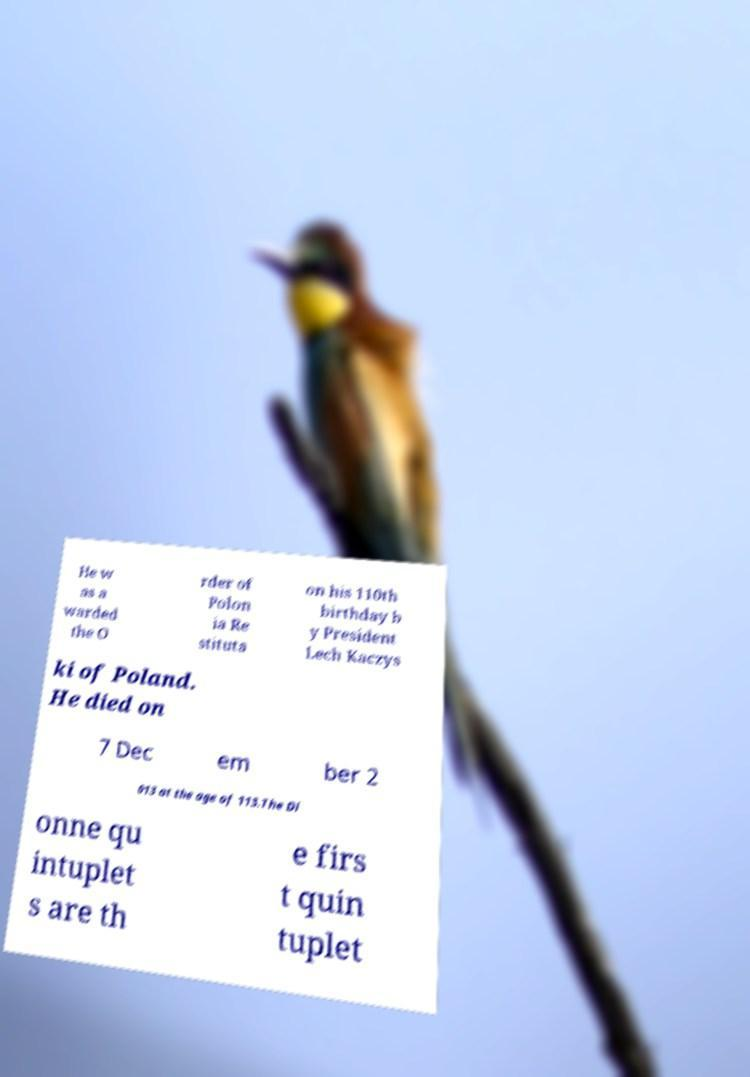Please identify and transcribe the text found in this image. He w as a warded the O rder of Polon ia Re stituta on his 110th birthday b y President Lech Kaczys ki of Poland. He died on 7 Dec em ber 2 013 at the age of 113.The Di onne qu intuplet s are th e firs t quin tuplet 